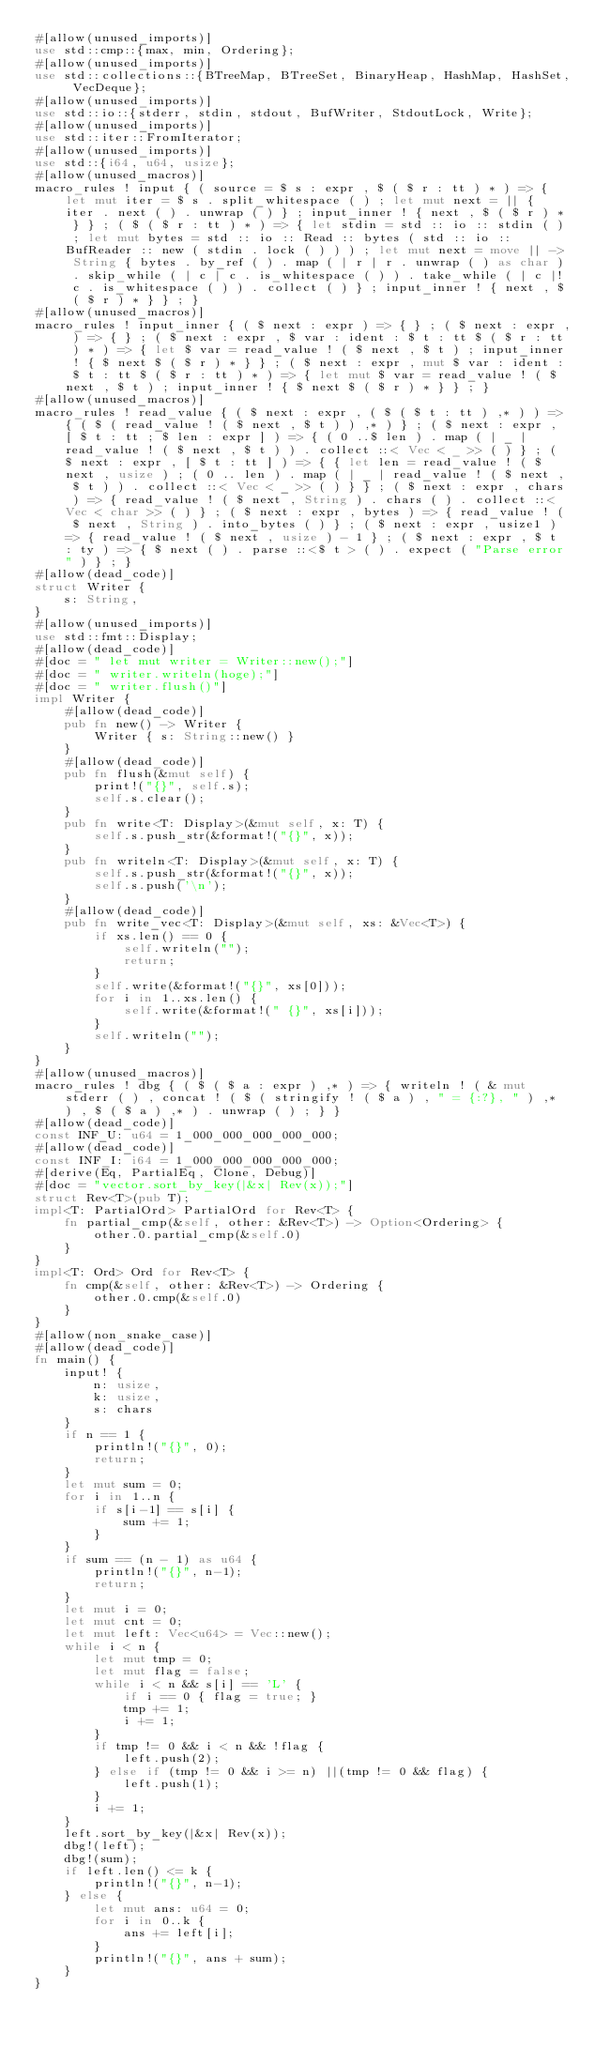Convert code to text. <code><loc_0><loc_0><loc_500><loc_500><_Rust_>#[allow(unused_imports)]
use std::cmp::{max, min, Ordering};
#[allow(unused_imports)]
use std::collections::{BTreeMap, BTreeSet, BinaryHeap, HashMap, HashSet, VecDeque};
#[allow(unused_imports)]
use std::io::{stderr, stdin, stdout, BufWriter, StdoutLock, Write};
#[allow(unused_imports)]
use std::iter::FromIterator;
#[allow(unused_imports)]
use std::{i64, u64, usize};
#[allow(unused_macros)]
macro_rules ! input { ( source = $ s : expr , $ ( $ r : tt ) * ) => { let mut iter = $ s . split_whitespace ( ) ; let mut next = || { iter . next ( ) . unwrap ( ) } ; input_inner ! { next , $ ( $ r ) * } } ; ( $ ( $ r : tt ) * ) => { let stdin = std :: io :: stdin ( ) ; let mut bytes = std :: io :: Read :: bytes ( std :: io :: BufReader :: new ( stdin . lock ( ) ) ) ; let mut next = move || -> String { bytes . by_ref ( ) . map ( | r | r . unwrap ( ) as char ) . skip_while ( | c | c . is_whitespace ( ) ) . take_while ( | c |! c . is_whitespace ( ) ) . collect ( ) } ; input_inner ! { next , $ ( $ r ) * } } ; }
#[allow(unused_macros)]
macro_rules ! input_inner { ( $ next : expr ) => { } ; ( $ next : expr , ) => { } ; ( $ next : expr , $ var : ident : $ t : tt $ ( $ r : tt ) * ) => { let $ var = read_value ! ( $ next , $ t ) ; input_inner ! { $ next $ ( $ r ) * } } ; ( $ next : expr , mut $ var : ident : $ t : tt $ ( $ r : tt ) * ) => { let mut $ var = read_value ! ( $ next , $ t ) ; input_inner ! { $ next $ ( $ r ) * } } ; }
#[allow(unused_macros)]
macro_rules ! read_value { ( $ next : expr , ( $ ( $ t : tt ) ,* ) ) => { ( $ ( read_value ! ( $ next , $ t ) ) ,* ) } ; ( $ next : expr , [ $ t : tt ; $ len : expr ] ) => { ( 0 ..$ len ) . map ( | _ | read_value ! ( $ next , $ t ) ) . collect ::< Vec < _ >> ( ) } ; ( $ next : expr , [ $ t : tt ] ) => { { let len = read_value ! ( $ next , usize ) ; ( 0 .. len ) . map ( | _ | read_value ! ( $ next , $ t ) ) . collect ::< Vec < _ >> ( ) } } ; ( $ next : expr , chars ) => { read_value ! ( $ next , String ) . chars ( ) . collect ::< Vec < char >> ( ) } ; ( $ next : expr , bytes ) => { read_value ! ( $ next , String ) . into_bytes ( ) } ; ( $ next : expr , usize1 ) => { read_value ! ( $ next , usize ) - 1 } ; ( $ next : expr , $ t : ty ) => { $ next ( ) . parse ::<$ t > ( ) . expect ( "Parse error" ) } ; }
#[allow(dead_code)]
struct Writer {
    s: String,
}
#[allow(unused_imports)]
use std::fmt::Display;
#[allow(dead_code)]
#[doc = " let mut writer = Writer::new();"]
#[doc = " writer.writeln(hoge);"]
#[doc = " writer.flush()"]
impl Writer {
    #[allow(dead_code)]
    pub fn new() -> Writer {
        Writer { s: String::new() }
    }
    #[allow(dead_code)]
    pub fn flush(&mut self) {
        print!("{}", self.s);
        self.s.clear();
    }
    pub fn write<T: Display>(&mut self, x: T) {
        self.s.push_str(&format!("{}", x));
    }
    pub fn writeln<T: Display>(&mut self, x: T) {
        self.s.push_str(&format!("{}", x));
        self.s.push('\n');
    }
    #[allow(dead_code)]
    pub fn write_vec<T: Display>(&mut self, xs: &Vec<T>) {
        if xs.len() == 0 {
            self.writeln("");
            return;
        }
        self.write(&format!("{}", xs[0]));
        for i in 1..xs.len() {
            self.write(&format!(" {}", xs[i]));
        }
        self.writeln("");
    }
}
#[allow(unused_macros)]
macro_rules ! dbg { ( $ ( $ a : expr ) ,* ) => { writeln ! ( & mut stderr ( ) , concat ! ( $ ( stringify ! ( $ a ) , " = {:?}, " ) ,* ) , $ ( $ a ) ,* ) . unwrap ( ) ; } }
#[allow(dead_code)]
const INF_U: u64 = 1_000_000_000_000_000;
#[allow(dead_code)]
const INF_I: i64 = 1_000_000_000_000_000;
#[derive(Eq, PartialEq, Clone, Debug)]
#[doc = "vector.sort_by_key(|&x| Rev(x));"]
struct Rev<T>(pub T);
impl<T: PartialOrd> PartialOrd for Rev<T> {
    fn partial_cmp(&self, other: &Rev<T>) -> Option<Ordering> {
        other.0.partial_cmp(&self.0)
    }
}
impl<T: Ord> Ord for Rev<T> {
    fn cmp(&self, other: &Rev<T>) -> Ordering {
        other.0.cmp(&self.0)
    }
}
#[allow(non_snake_case)]
#[allow(dead_code)]
fn main() {
    input! {
        n: usize,
        k: usize,
        s: chars
    }
    if n == 1 {
        println!("{}", 0);
        return;
    }
    let mut sum = 0;
    for i in 1..n {
        if s[i-1] == s[i] {
            sum += 1;
        }
    }
    if sum == (n - 1) as u64 {
        println!("{}", n-1);
        return;
    }
    let mut i = 0;
    let mut cnt = 0;
    let mut left: Vec<u64> = Vec::new();
    while i < n {
        let mut tmp = 0;
        let mut flag = false;
        while i < n && s[i] == 'L' {
            if i == 0 { flag = true; }
            tmp += 1;
            i += 1;
        }
        if tmp != 0 && i < n && !flag {
            left.push(2);
        } else if (tmp != 0 && i >= n) ||(tmp != 0 && flag) {
            left.push(1);
        }
        i += 1;
    }
    left.sort_by_key(|&x| Rev(x));
    dbg!(left);
    dbg!(sum);
    if left.len() <= k {
        println!("{}", n-1);
    } else {
        let mut ans: u64 = 0;
        for i in 0..k {
            ans += left[i];
        }
        println!("{}", ans + sum);
    }
}</code> 